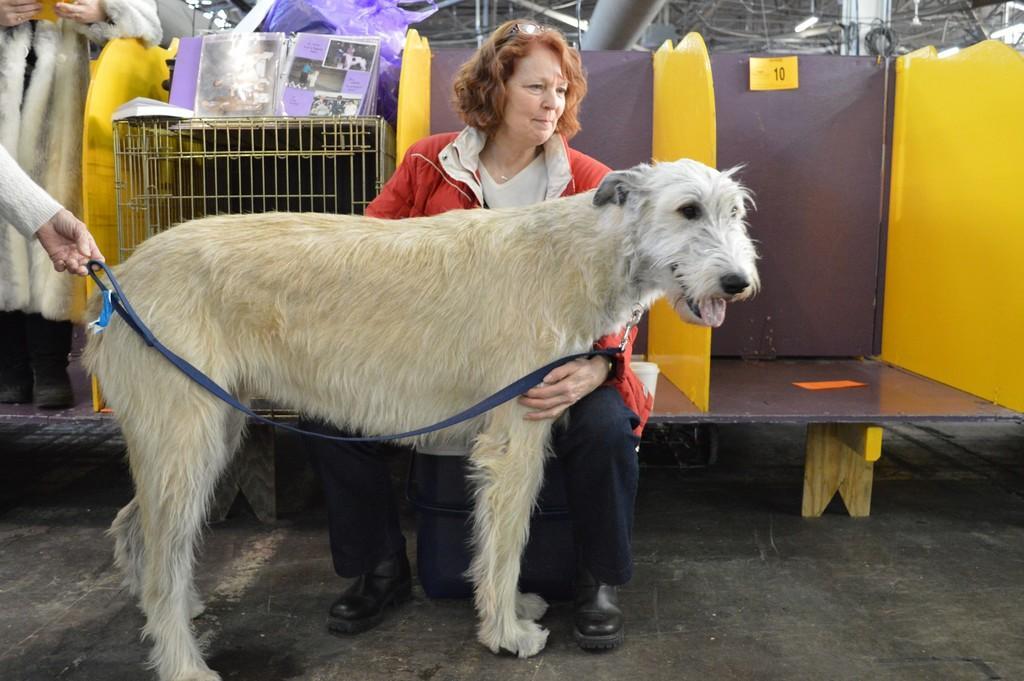Please provide a concise description of this image. In the center of the image there is a dog and behind the dog there is a woman sitting on the bench. In the background we can see some books on the rack. There is also some person. At the bottom there is floor. 